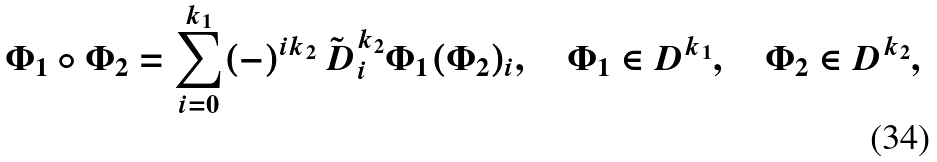Convert formula to latex. <formula><loc_0><loc_0><loc_500><loc_500>\Phi _ { 1 } \circ \Phi _ { 2 } = \sum _ { i = 0 } ^ { k _ { 1 } } ( - ) ^ { i k _ { 2 } } \tilde { \ D } ^ { k _ { 2 } } _ { i } \Phi _ { 1 } ( \Phi _ { 2 } ) _ { i } , \quad \Phi _ { 1 } \in D ^ { k _ { 1 } } , \quad \Phi _ { 2 } \in D ^ { k _ { 2 } } ,</formula> 